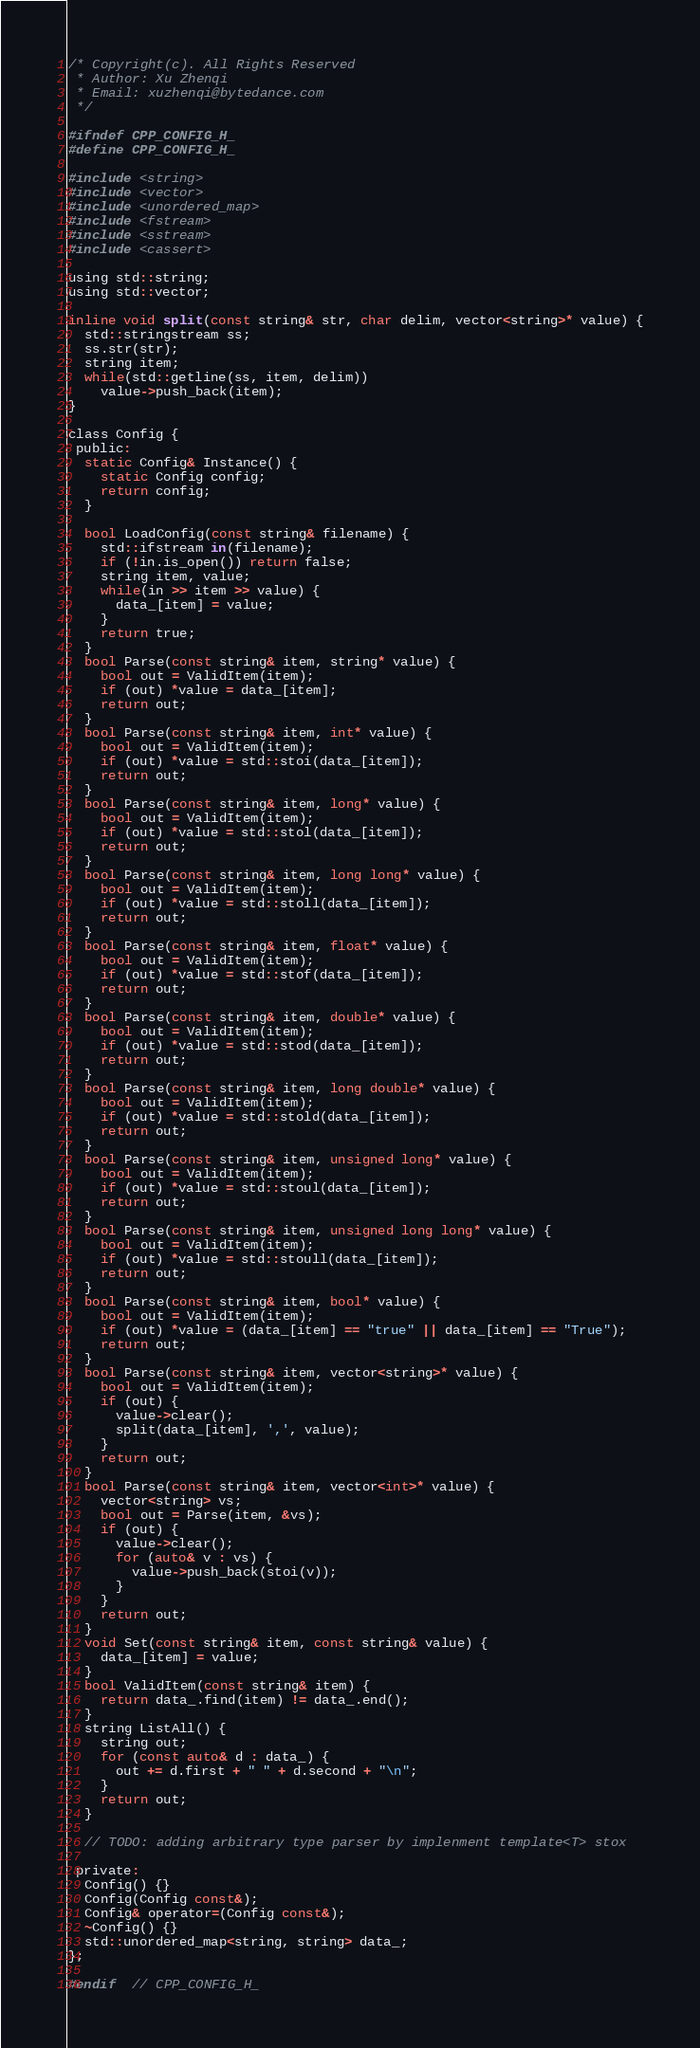Convert code to text. <code><loc_0><loc_0><loc_500><loc_500><_C_>/* Copyright(c). All Rights Reserved
 * Author: Xu Zhenqi
 * Email: xuzhenqi@bytedance.com
 */

#ifndef CPP_CONFIG_H_
#define CPP_CONFIG_H_

#include <string>
#include <vector>
#include <unordered_map>
#include <fstream>
#include <sstream>
#include <cassert>

using std::string;
using std::vector;

inline void split(const string& str, char delim, vector<string>* value) {
  std::stringstream ss;
  ss.str(str);
  string item;
  while(std::getline(ss, item, delim)) 
    value->push_back(item);
}

class Config {
 public:
  static Config& Instance() {
    static Config config;
    return config;
  }

  bool LoadConfig(const string& filename) {
    std::ifstream in(filename);
    if (!in.is_open()) return false;
    string item, value;
    while(in >> item >> value) {
      data_[item] = value;
    }
    return true;
  }
  bool Parse(const string& item, string* value) {
    bool out = ValidItem(item);
    if (out) *value = data_[item];
    return out;
  }
  bool Parse(const string& item, int* value) {
    bool out = ValidItem(item);
    if (out) *value = std::stoi(data_[item]);
    return out;
  }
  bool Parse(const string& item, long* value) {
    bool out = ValidItem(item);
    if (out) *value = std::stol(data_[item]);
    return out;
  }
  bool Parse(const string& item, long long* value) {
    bool out = ValidItem(item);
    if (out) *value = std::stoll(data_[item]);
    return out;
  }
  bool Parse(const string& item, float* value) {
    bool out = ValidItem(item);
    if (out) *value = std::stof(data_[item]);
    return out;
  }
  bool Parse(const string& item, double* value) {
    bool out = ValidItem(item);
    if (out) *value = std::stod(data_[item]);
    return out;
  }
  bool Parse(const string& item, long double* value) {
    bool out = ValidItem(item);
    if (out) *value = std::stold(data_[item]);
    return out;
  }
  bool Parse(const string& item, unsigned long* value) {
    bool out = ValidItem(item);
    if (out) *value = std::stoul(data_[item]);
    return out;
  }
  bool Parse(const string& item, unsigned long long* value) {
    bool out = ValidItem(item);
    if (out) *value = std::stoull(data_[item]);
    return out;
  }
  bool Parse(const string& item, bool* value) {
    bool out = ValidItem(item);
    if (out) *value = (data_[item] == "true" || data_[item] == "True");
    return out;
  }
  bool Parse(const string& item, vector<string>* value) {
    bool out = ValidItem(item);
    if (out) {
      value->clear();
      split(data_[item], ',', value);
    }
    return out;
  }
  bool Parse(const string& item, vector<int>* value) {
    vector<string> vs;
    bool out = Parse(item, &vs);
    if (out) {
      value->clear();
      for (auto& v : vs) {
        value->push_back(stoi(v));
      }
    }
    return out;
  }
  void Set(const string& item, const string& value) {
    data_[item] = value;
  }
  bool ValidItem(const string& item) {
    return data_.find(item) != data_.end();
  }
  string ListAll() {
    string out;
    for (const auto& d : data_) {
      out += d.first + " " + d.second + "\n";
    }
    return out;
  }

  // TODO: adding arbitrary type parser by implenment template<T> stox
  
 private:
  Config() {}
  Config(Config const&); 
  Config& operator=(Config const&);
  ~Config() {}
  std::unordered_map<string, string> data_;
};

#endif  // CPP_CONFIG_H_
</code> 